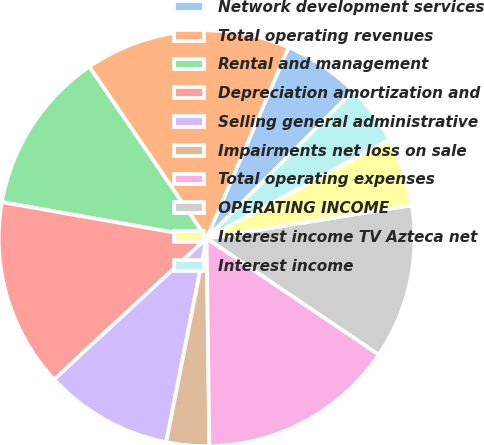Convert chart to OTSL. <chart><loc_0><loc_0><loc_500><loc_500><pie_chart><fcel>Network development services<fcel>Total operating revenues<fcel>Rental and management<fcel>Depreciation amortization and<fcel>Selling general administrative<fcel>Impairments net loss on sale<fcel>Total operating expenses<fcel>OPERATING INCOME<fcel>Interest income TV Azteca net<fcel>Interest income<nl><fcel>6.0%<fcel>16.0%<fcel>12.67%<fcel>14.67%<fcel>10.0%<fcel>3.33%<fcel>15.33%<fcel>12.0%<fcel>5.33%<fcel>4.67%<nl></chart> 